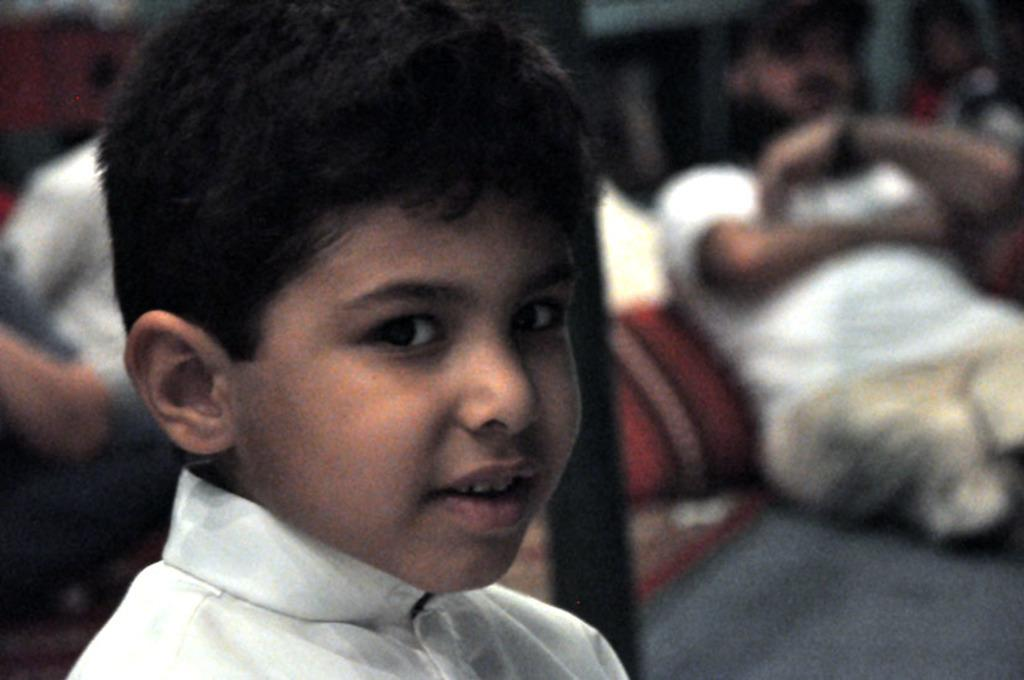Who is the main subject in the image? There is a boy in the center of the image. Can you describe the surroundings of the boy? There are other people in the background of the image. What type of trade is being conducted by the giraffe in the image? There is no giraffe present in the image, so no trade can be observed. 